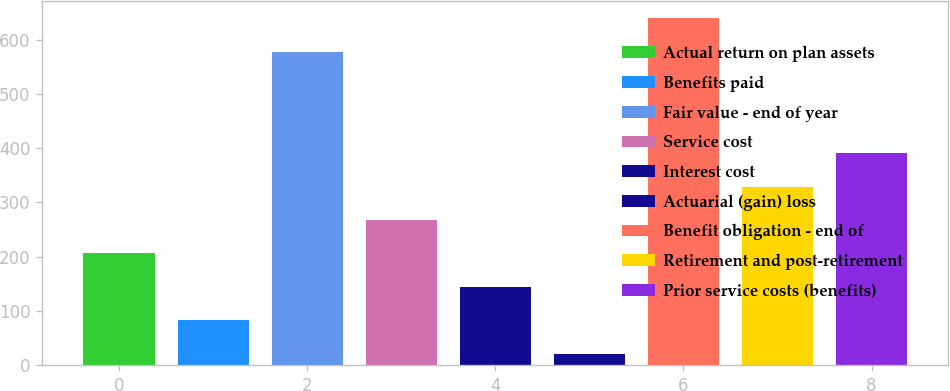<chart> <loc_0><loc_0><loc_500><loc_500><bar_chart><fcel>Actual return on plan assets<fcel>Benefits paid<fcel>Fair value - end of year<fcel>Service cost<fcel>Interest cost<fcel>Actuarial (gain) loss<fcel>Benefit obligation - end of<fcel>Retirement and post-retirement<fcel>Prior service costs (benefits)<nl><fcel>205.8<fcel>82.6<fcel>578<fcel>267.4<fcel>144.2<fcel>21<fcel>639.6<fcel>329<fcel>390.6<nl></chart> 